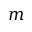<formula> <loc_0><loc_0><loc_500><loc_500>m</formula> 